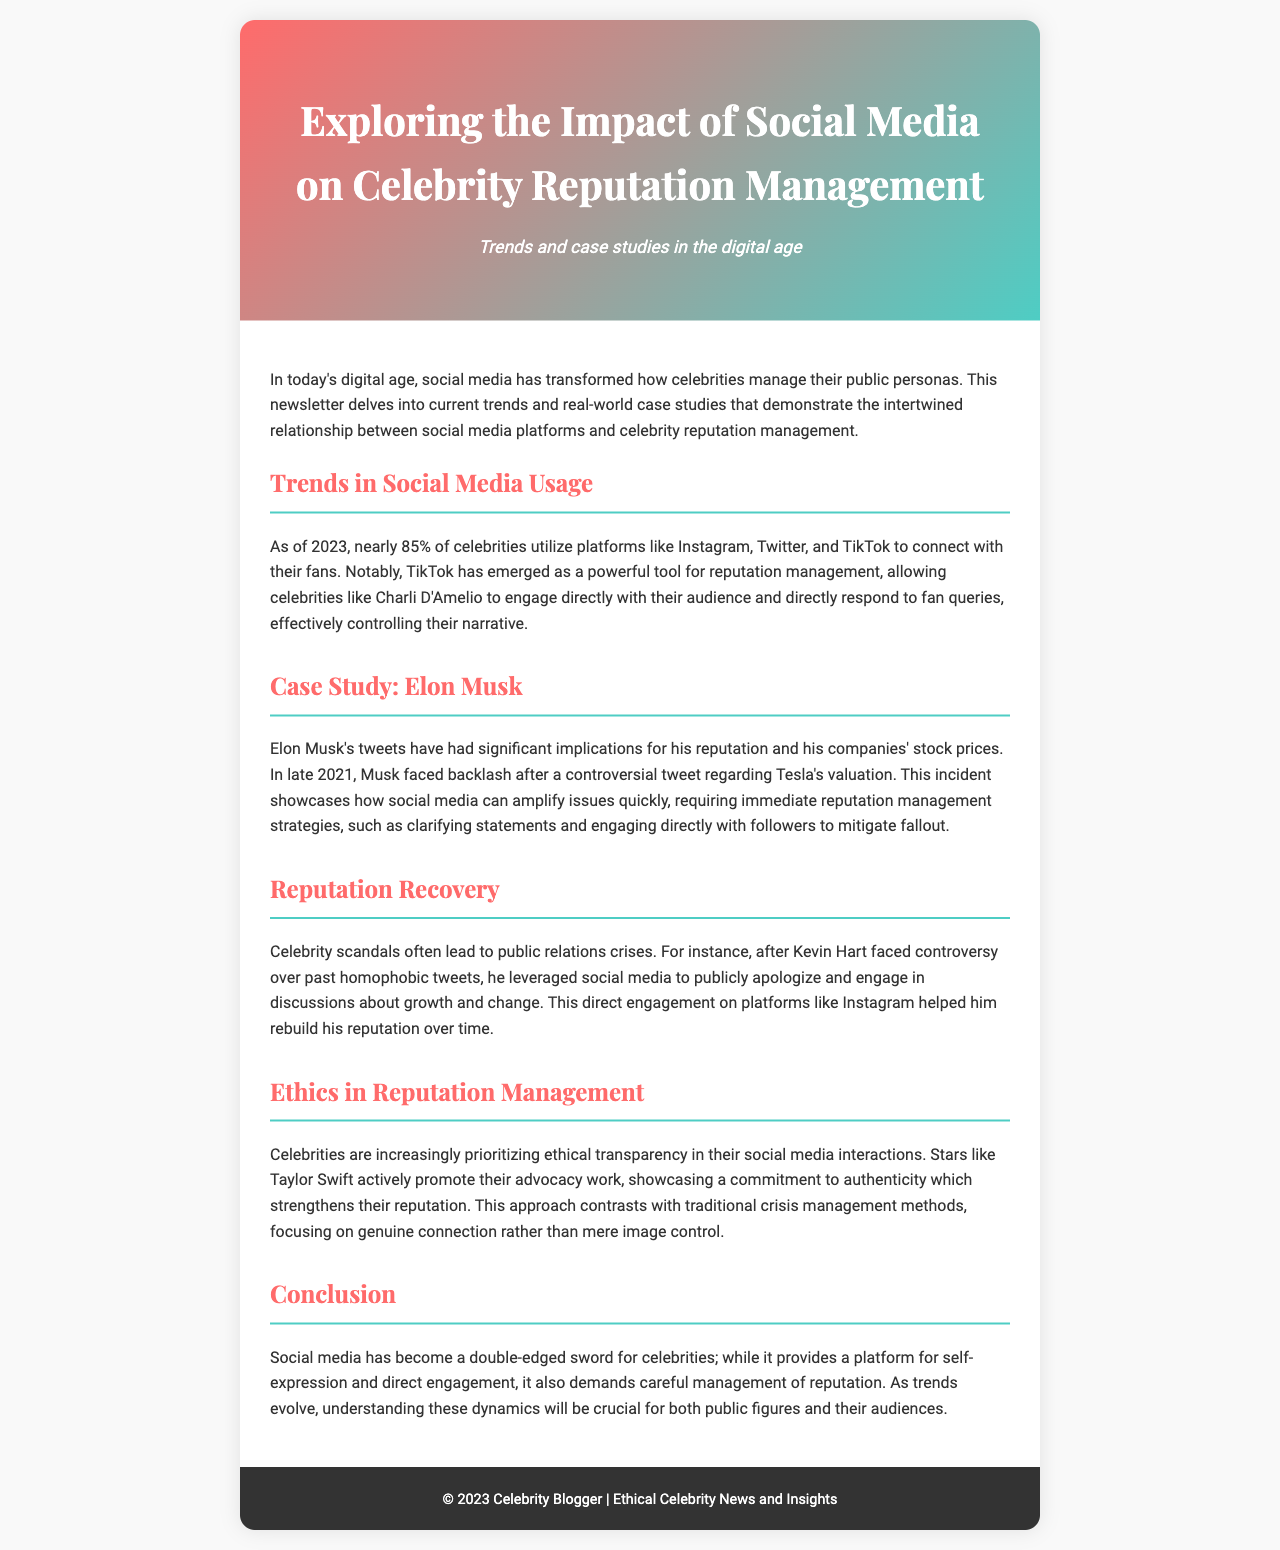What percentage of celebrities use social media? The document states that nearly 85% of celebrities utilize social media platforms.
Answer: 85% Who is highlighted in the case study about reputation management? The case study focuses specifically on Elon Musk and his social media impact.
Answer: Elon Musk What platform has emerged as a powerful tool for reputation management? The document mentions TikTok as an important platform for managing reputation.
Answer: TikTok Which celebrity publicly apologized for past tweets about homophobia? The document refers to Kevin Hart's scandal and subsequent public apology.
Answer: Kevin Hart What is a key trend noted in the document related to celebrity social media interactions? The newsletter mentions ethical transparency as a growing trend among celebrities.
Answer: Ethical transparency What year did Elon Musk face backlash for a controversial tweet? The document specifies that the incident occurred in late 2021.
Answer: 2021 Which celebrity actively promotes their advocacy work on social media? The document highlights Taylor Swift's commitment to authenticity and advocacy.
Answer: Taylor Swift What is the primary purpose of the newsletter? The main focus is exploring the impact of social media on celebrity reputation management.
Answer: Reputation management What type of crises do celebrity scandals often lead to? The document mentions public relations crises as a common result of scandals.
Answer: Public relations crises 